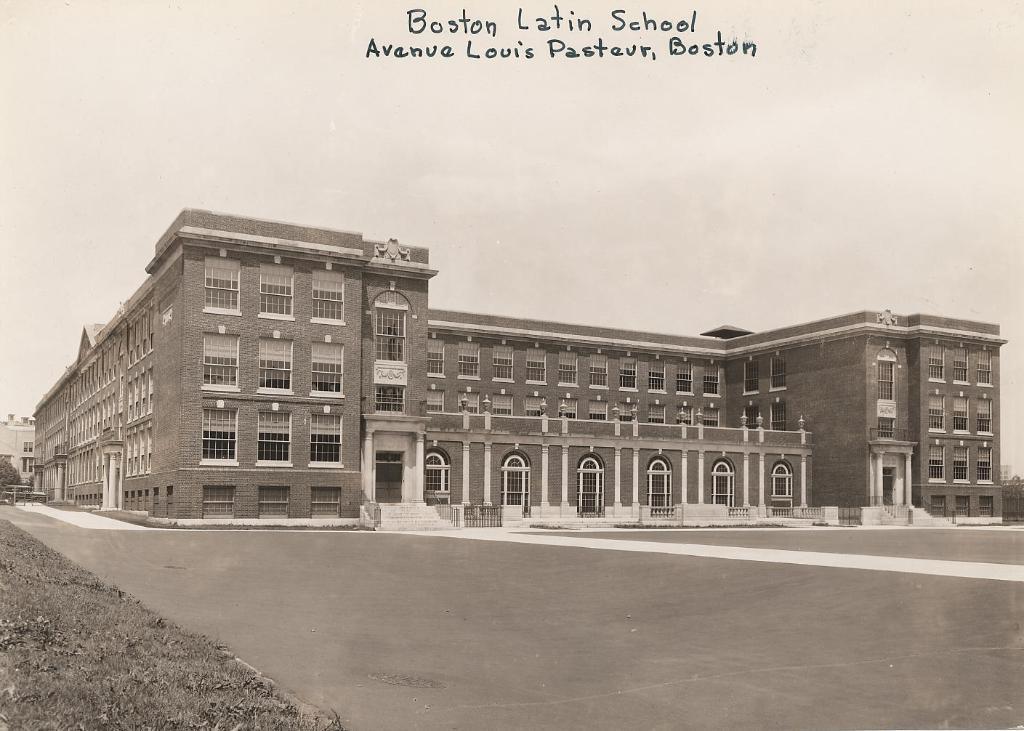Can you describe this image briefly? At the top portion of the picture there is something written. In this picture we can see a large building, windows, doors, pillars, stairs. We can see the railing. At the bottom portion of the picture we can see the road. On the left side of the picture we can see a tree, grass and far we can see a building. 